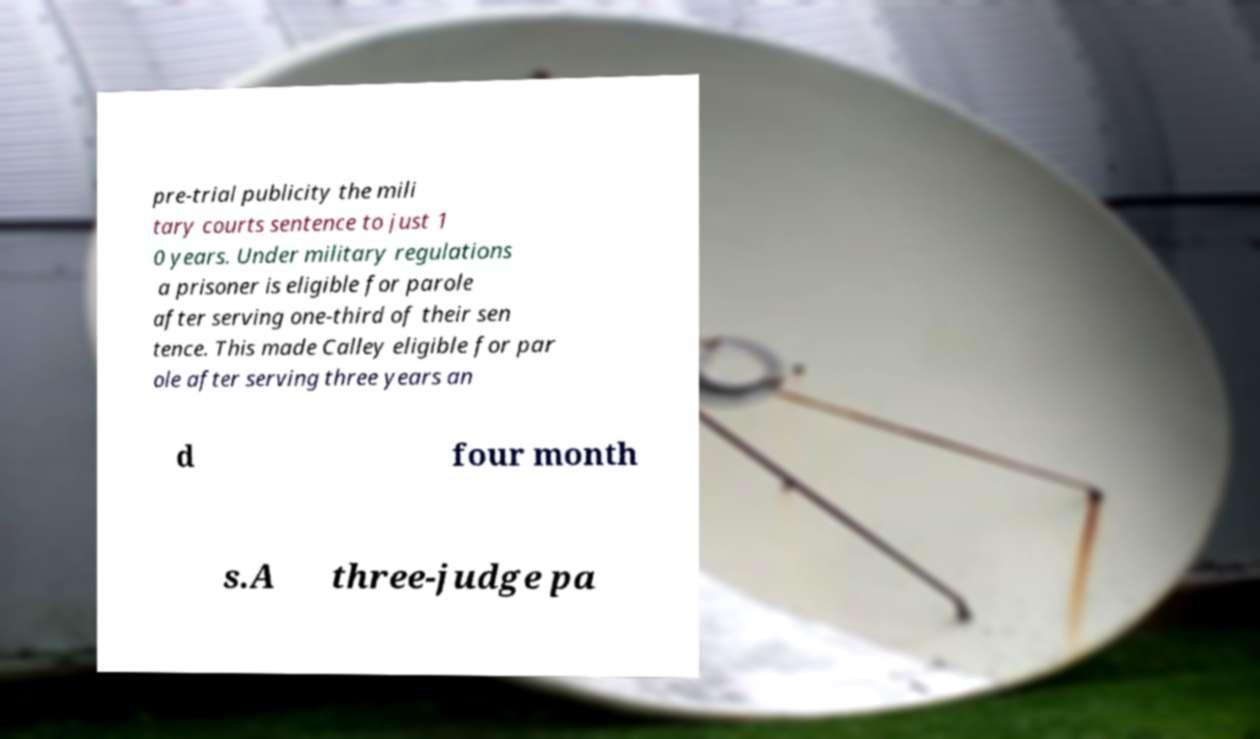For documentation purposes, I need the text within this image transcribed. Could you provide that? pre-trial publicity the mili tary courts sentence to just 1 0 years. Under military regulations a prisoner is eligible for parole after serving one-third of their sen tence. This made Calley eligible for par ole after serving three years an d four month s.A three-judge pa 